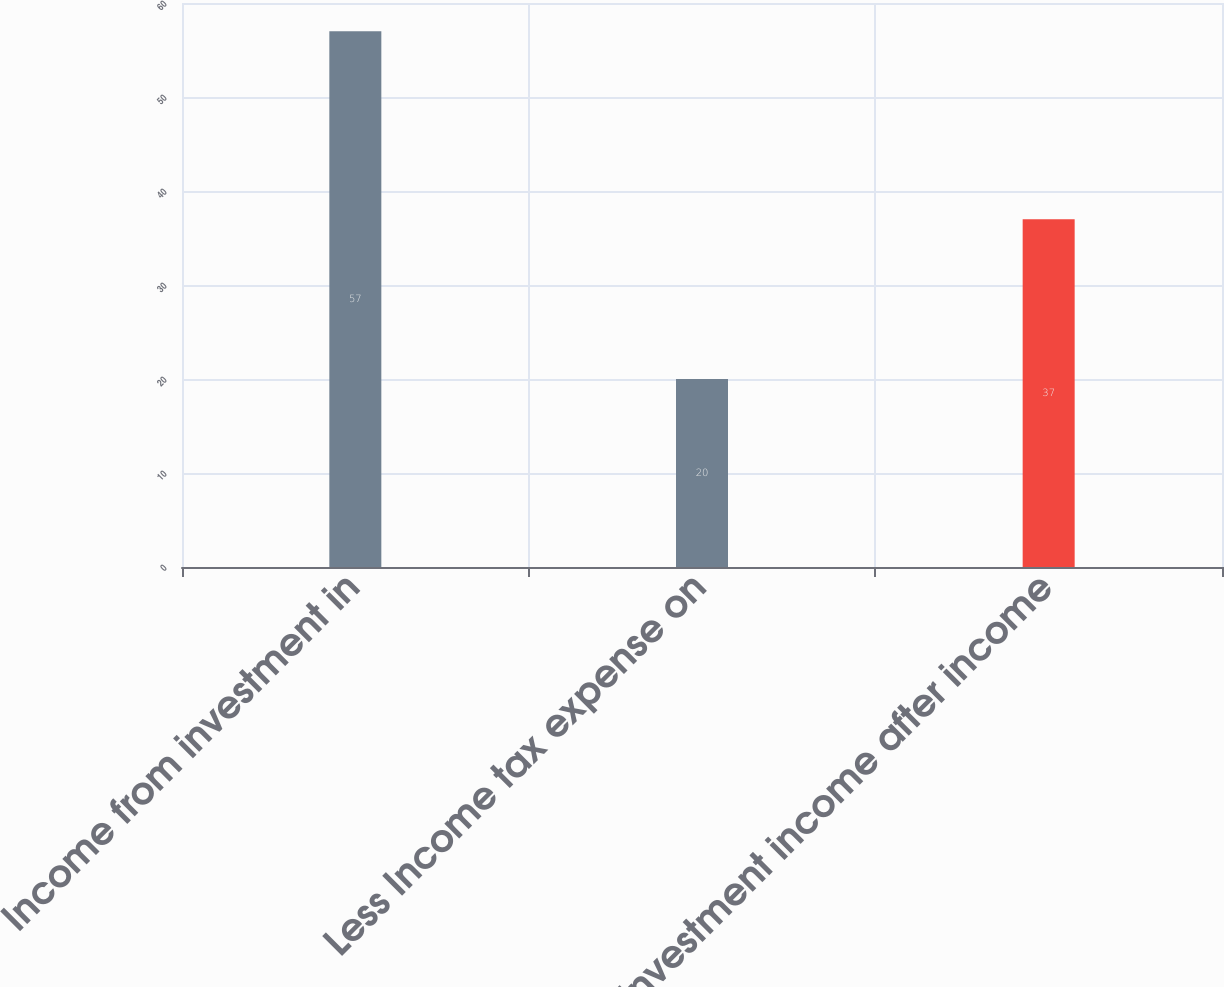Convert chart to OTSL. <chart><loc_0><loc_0><loc_500><loc_500><bar_chart><fcel>Income from investment in<fcel>Less Income tax expense on<fcel>Investment income after income<nl><fcel>57<fcel>20<fcel>37<nl></chart> 